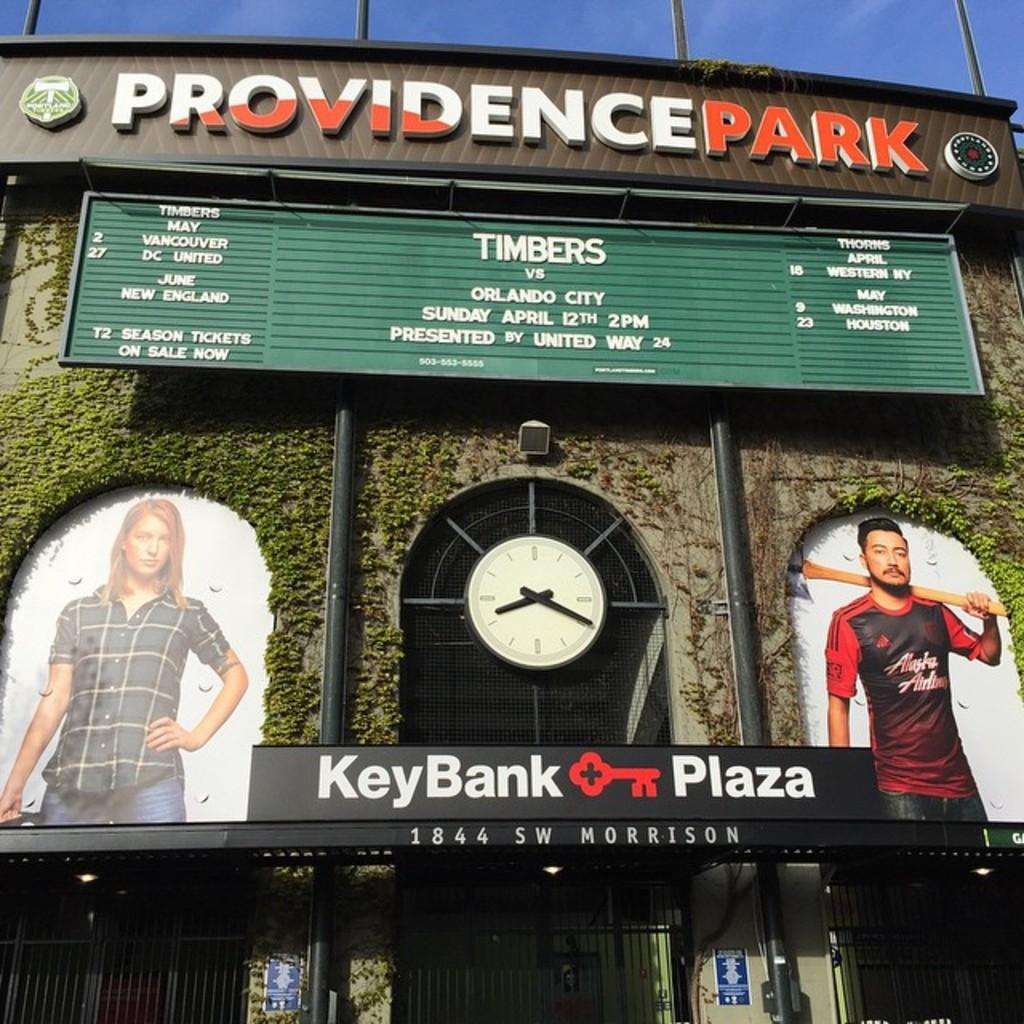<image>
Write a terse but informative summary of the picture. The facade of Providence Park stadium with a clock and a TImbers game. 